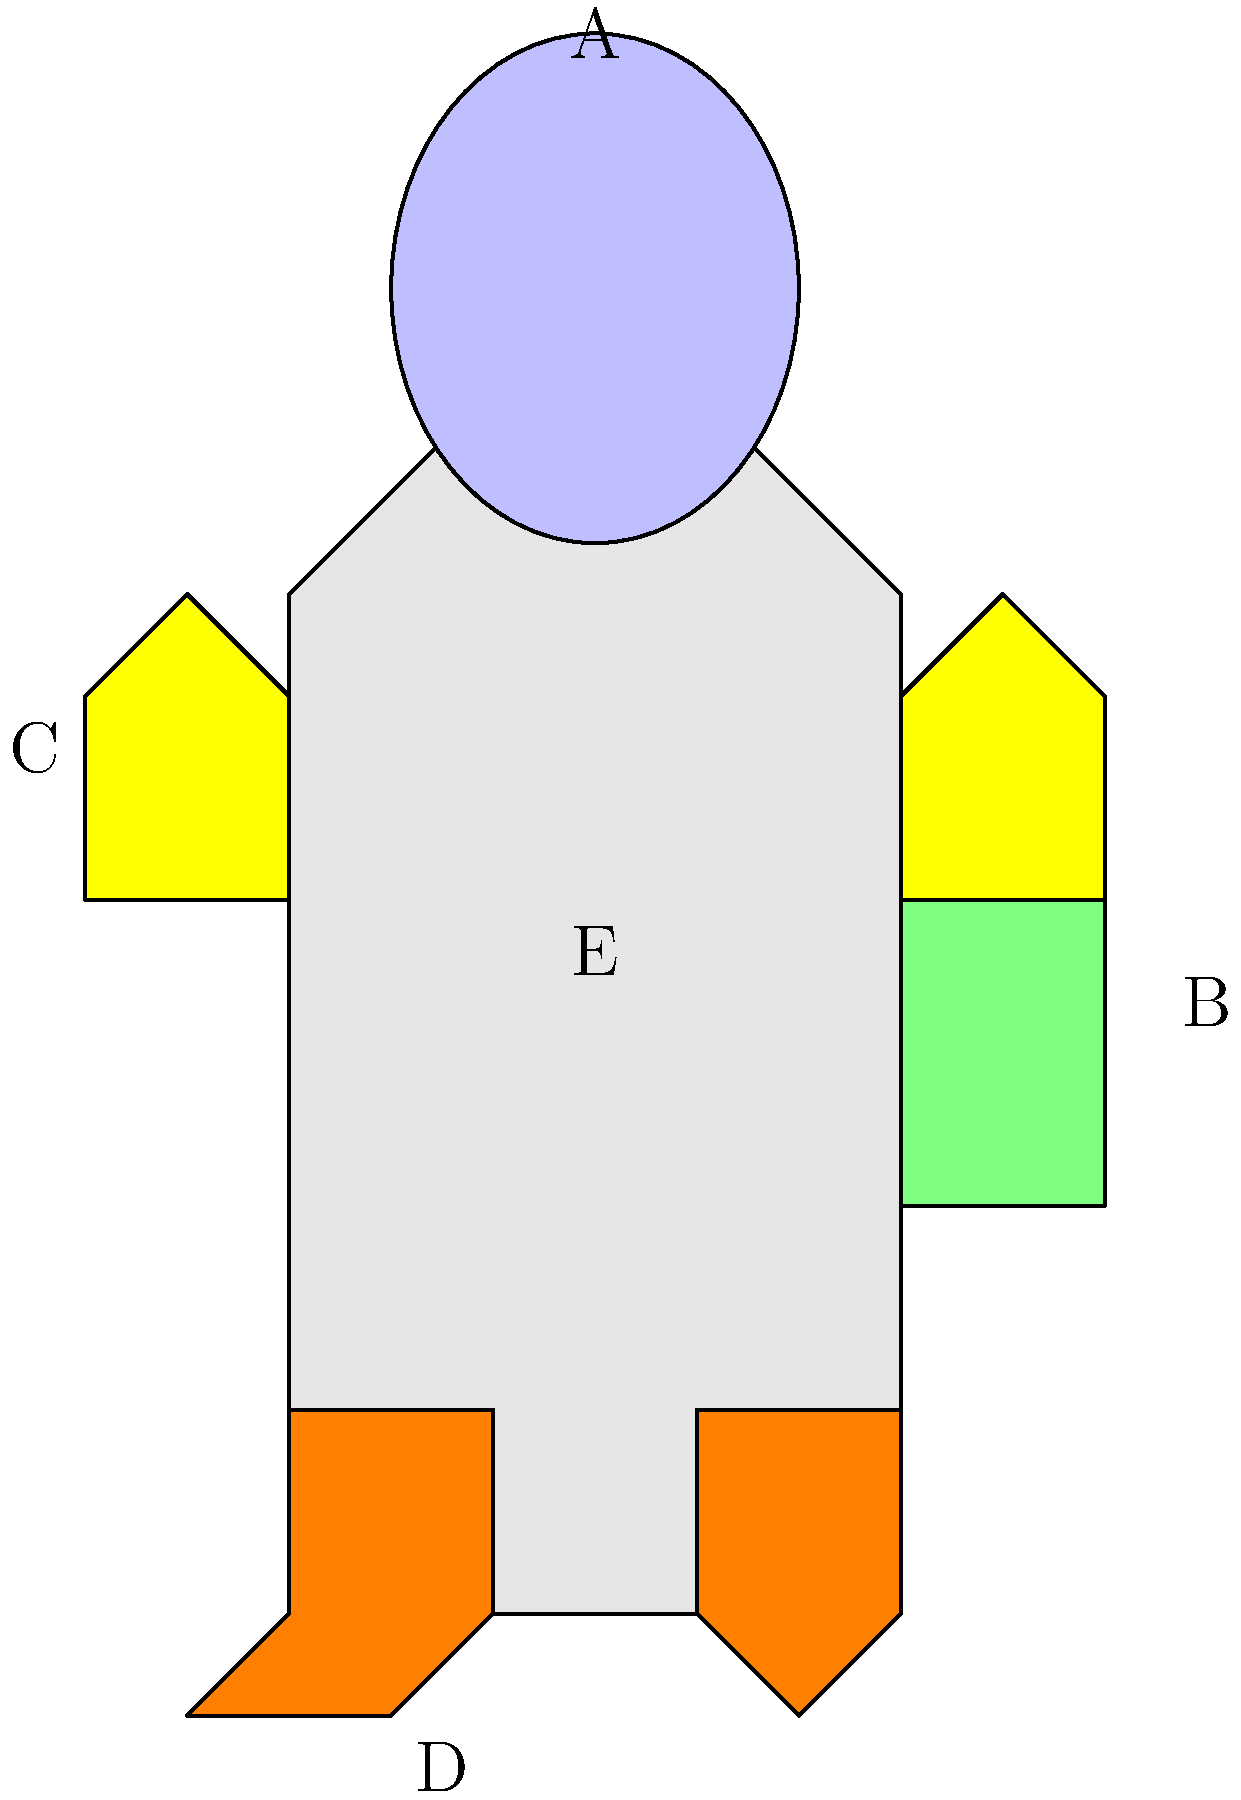As a caregiver who often listens to astronauts' stories, you've become familiar with their equipment. Can you correctly label the parts of this spacesuit diagram? Match the letters A-E to the following components: Helmet, Life Support System, Gloves, Boots, and Torso. Let's go through each component of the spacesuit step-by-step:

1. Helmet (A): The helmet is located at the top of the suit, protecting the astronaut's head. It's represented by the elliptical shape at the top of the diagram, labeled with 'A'.

2. Life Support System (B): This is the backpack-like structure on the back of the suit. It contains oxygen supply and other vital systems. In the diagram, it's the rectangular shape on the right side of the suit, labeled with 'B'.

3. Gloves (C): The gloves protect the astronaut's hands and allow for dexterity in space. They're shown as the protruding shapes on both sides of the suit's arms. The label 'C' points to the left glove.

4. Boots (D): The boots are at the bottom of the suit, protecting the astronaut's feet. They're represented by the shaped structures at the base of the suit. The label 'D' points to the left boot.

5. Torso (E): The torso is the main body of the spacesuit, protecting the astronaut's chest, abdomen, and legs. It's the central part of the suit, labeled with 'E'.

By matching these descriptions to the labeled parts in the diagram, we can correctly identify each component of the spacesuit.
Answer: A: Helmet, B: Life Support System, C: Gloves, D: Boots, E: Torso 